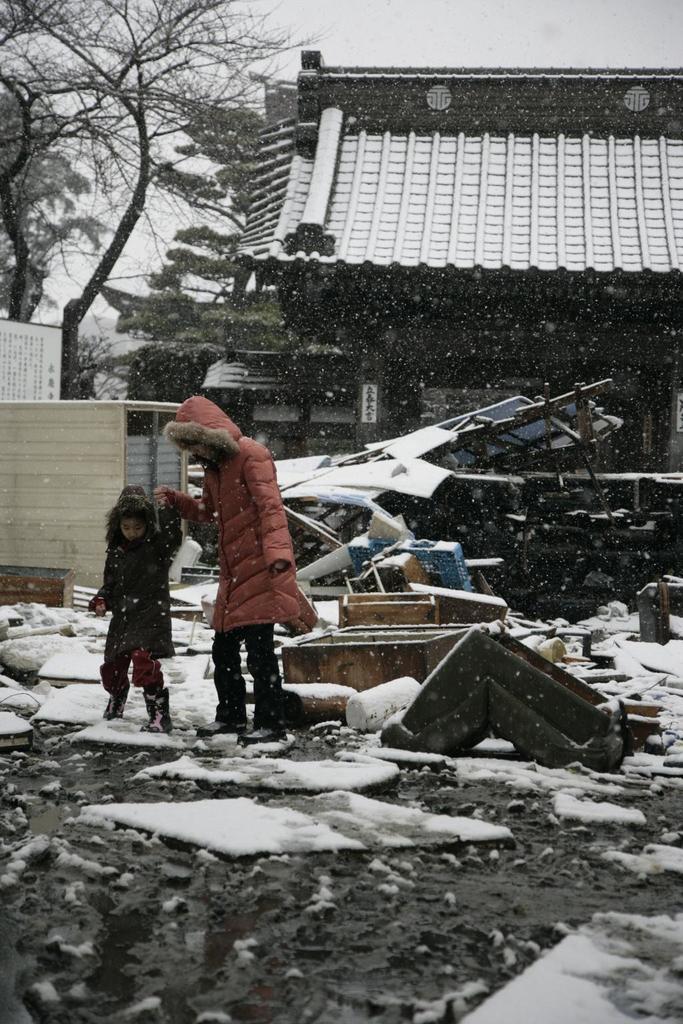Could you give a brief overview of what you see in this image? In the middle of the image two persons are walking. Behind them there are some poles and buildings and trees. At the top of the image there is sky. 